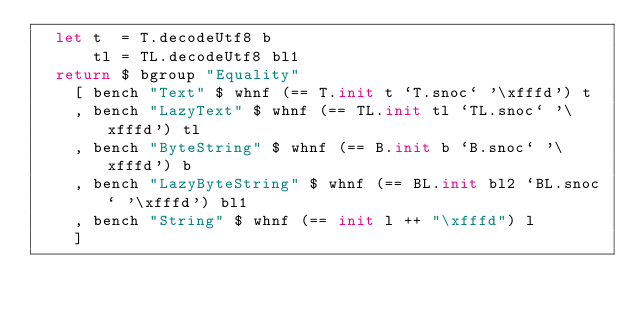<code> <loc_0><loc_0><loc_500><loc_500><_Haskell_>  let t  = T.decodeUtf8 b
      tl = TL.decodeUtf8 bl1
  return $ bgroup "Equality"
    [ bench "Text" $ whnf (== T.init t `T.snoc` '\xfffd') t
    , bench "LazyText" $ whnf (== TL.init tl `TL.snoc` '\xfffd') tl
    , bench "ByteString" $ whnf (== B.init b `B.snoc` '\xfffd') b
    , bench "LazyByteString" $ whnf (== BL.init bl2 `BL.snoc` '\xfffd') bl1
    , bench "String" $ whnf (== init l ++ "\xfffd") l
    ]
</code> 